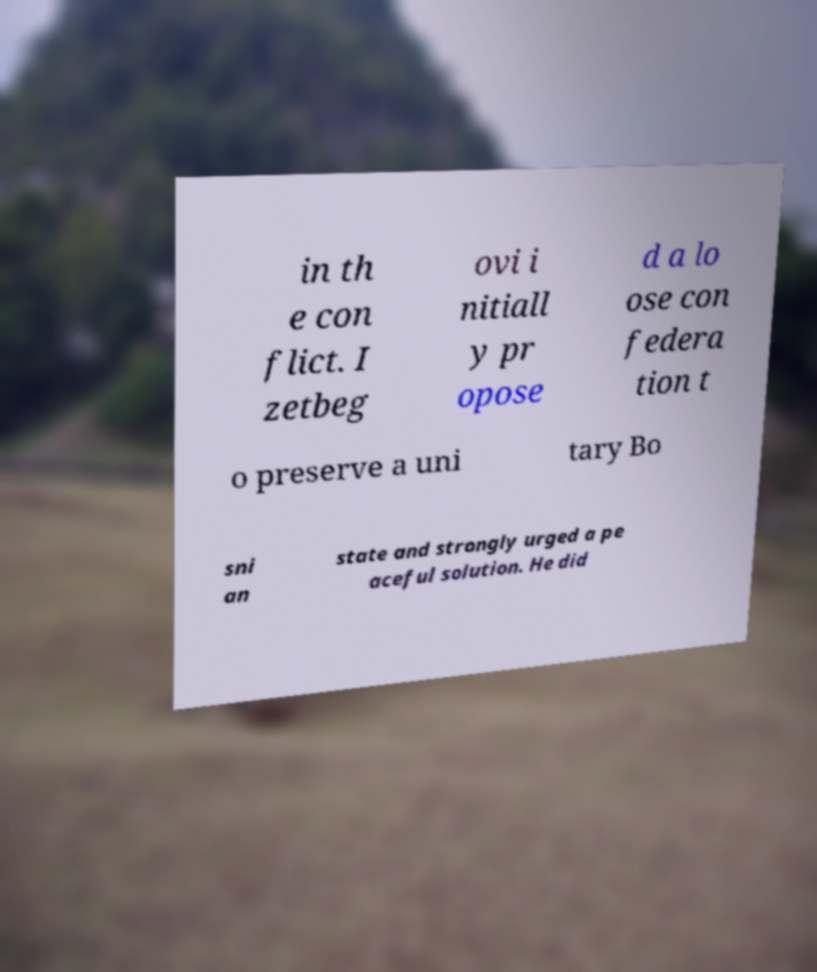What messages or text are displayed in this image? I need them in a readable, typed format. in th e con flict. I zetbeg ovi i nitiall y pr opose d a lo ose con federa tion t o preserve a uni tary Bo sni an state and strongly urged a pe aceful solution. He did 